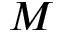Convert formula to latex. <formula><loc_0><loc_0><loc_500><loc_500>M</formula> 